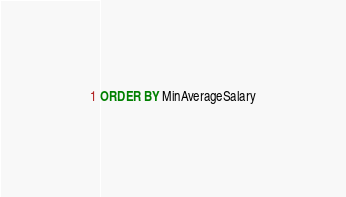Convert code to text. <code><loc_0><loc_0><loc_500><loc_500><_SQL_>ORDER BY MinAverageSalary




</code> 